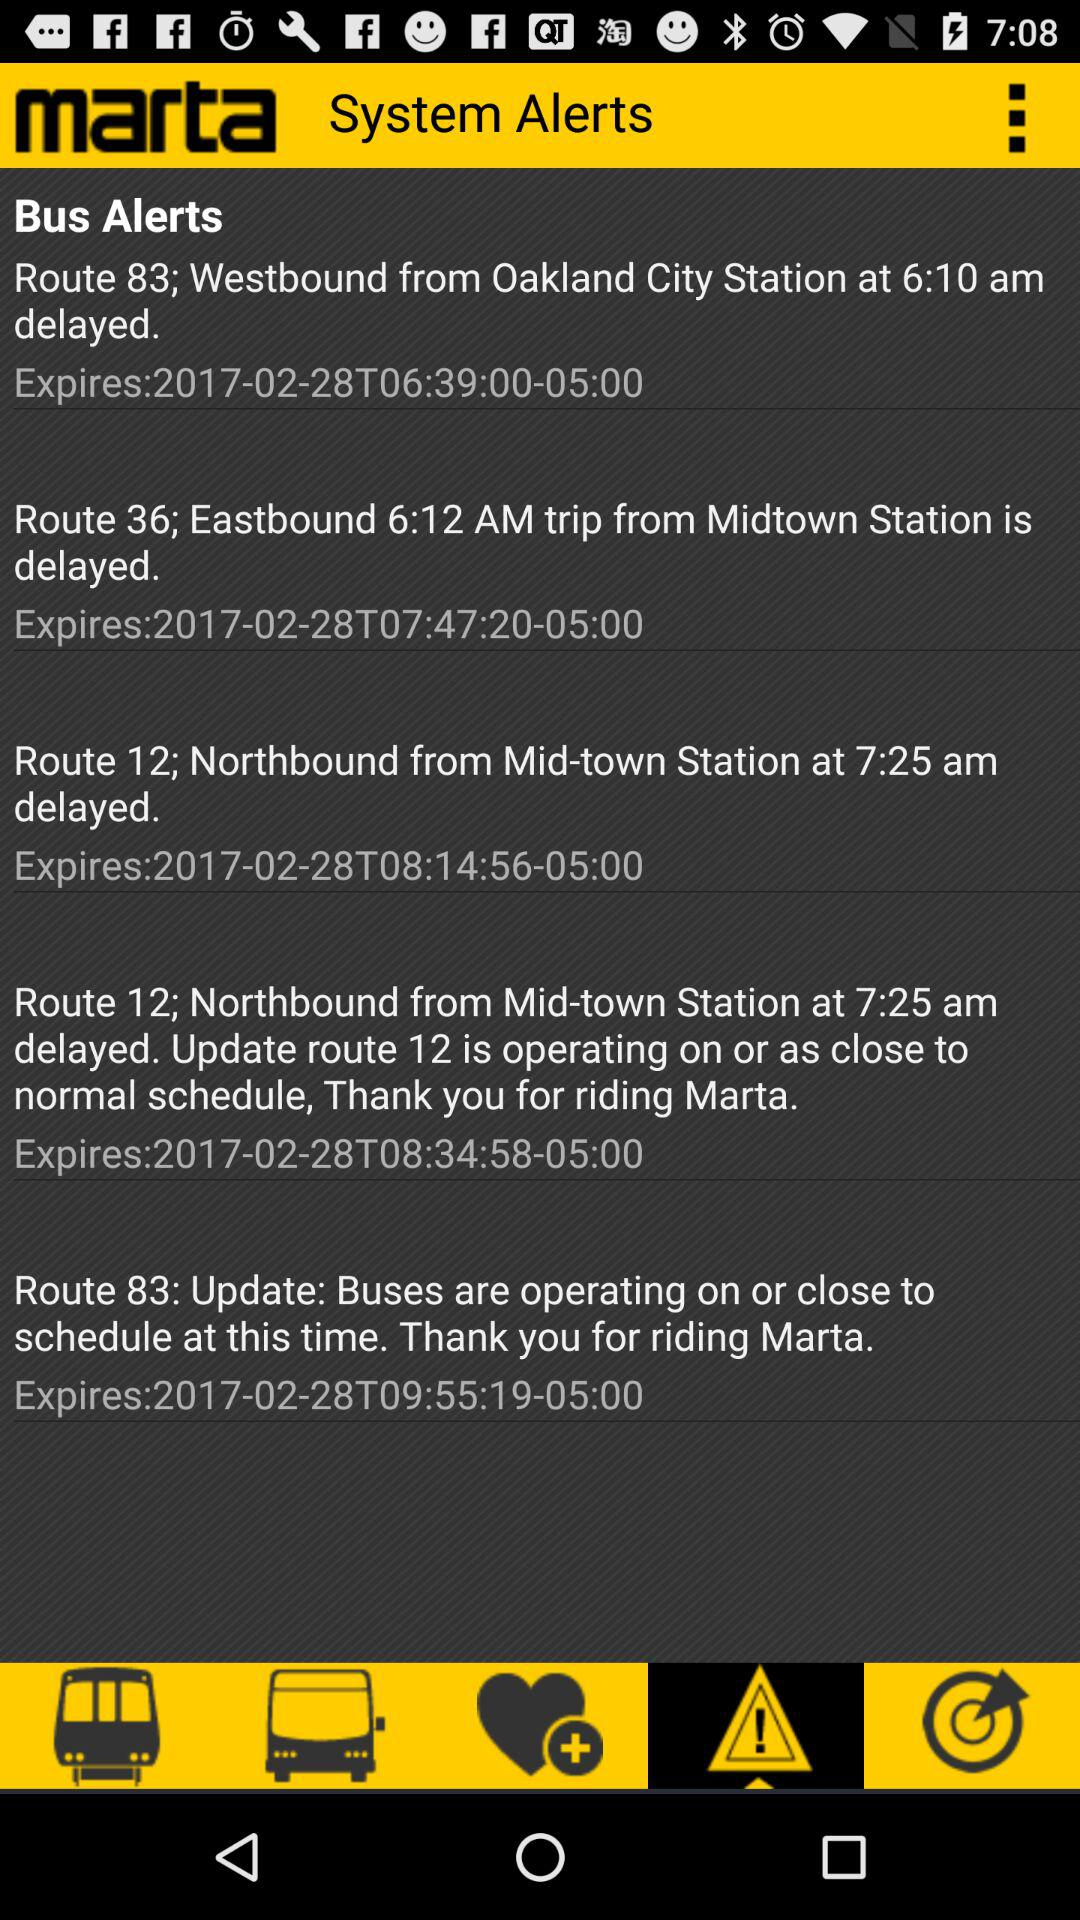What is the expiration date of the Route 12 bus alert? The expiration date of the Route 12 bus alert is February 28, 2017. 